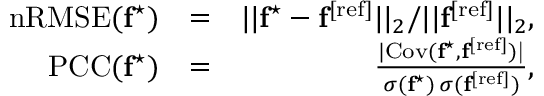Convert formula to latex. <formula><loc_0><loc_0><loc_500><loc_500>\begin{array} { r l r } { n R M S E ( f ^ { ^ { * } } ) } & { = } & { | | f ^ { ^ { * } } - f ^ { [ r e f ] } | | _ { 2 } / | | f ^ { [ r e f ] } | | _ { 2 } , } \\ { P C C ( f ^ { ^ { * } } ) } & { = } & { \frac { | C o v ( f ^ { ^ { * } } , f ^ { \mathrm { [ r e f ] } } ) | } { \sigma ( f ^ { ^ { * } } ) \, \sigma ( f ^ { [ r e f ] } ) } , } \end{array}</formula> 